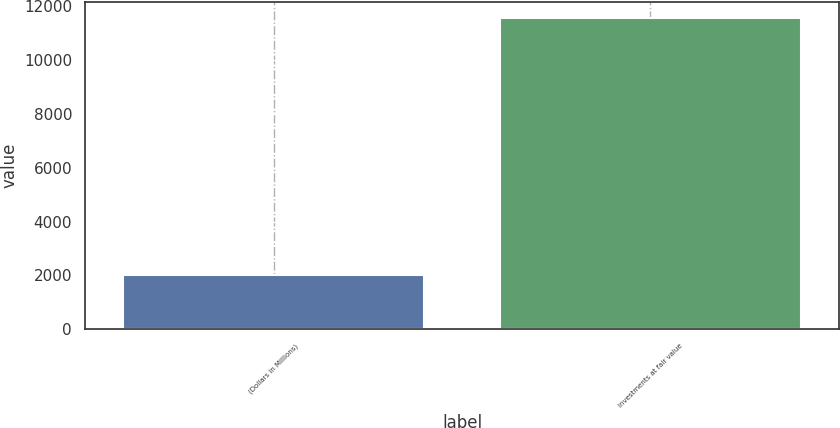<chart> <loc_0><loc_0><loc_500><loc_500><bar_chart><fcel>(Dollars in Millions)<fcel>Investments at fair value<nl><fcel>2016<fcel>11578<nl></chart> 